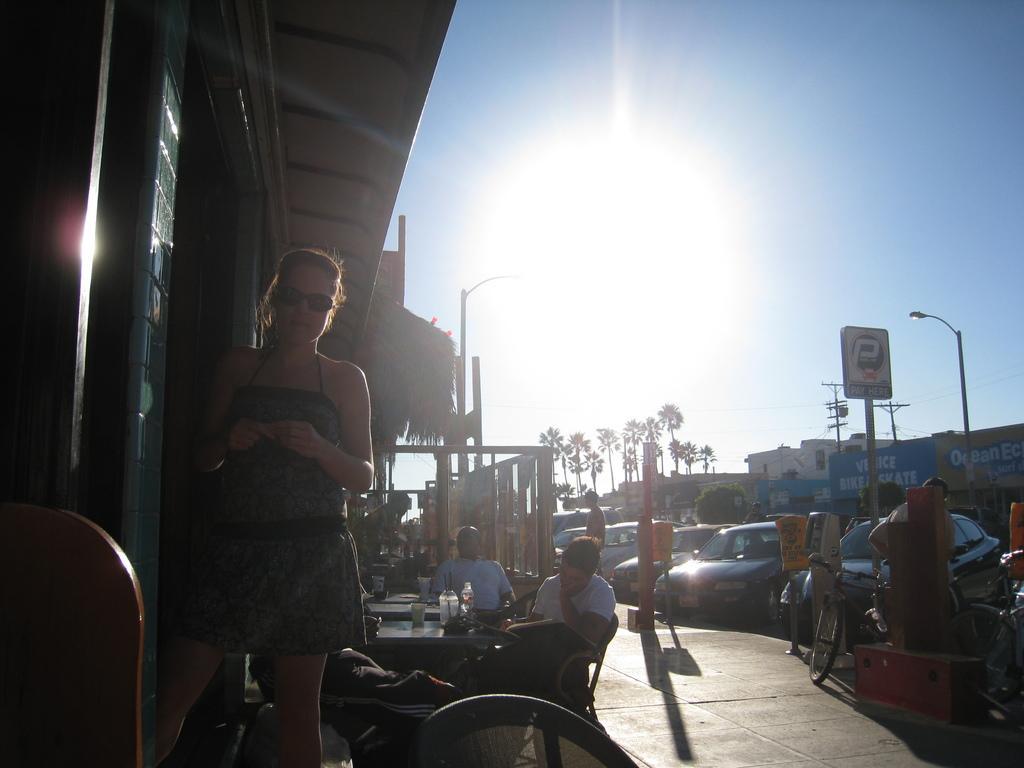Can you describe this image briefly? In this image we can see many vehicles parked. There are few people are sitting on the chairs. There are many stores and advertising boards in the image. There are many trees in the image. A lady is standing at the left side of the image. 